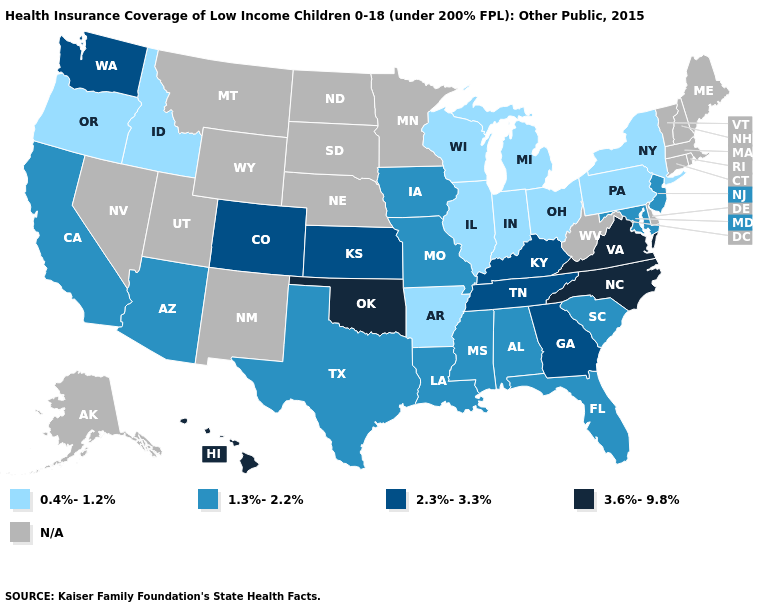Does the map have missing data?
Concise answer only. Yes. What is the value of Arkansas?
Keep it brief. 0.4%-1.2%. Which states hav the highest value in the MidWest?
Quick response, please. Kansas. Which states have the lowest value in the MidWest?
Write a very short answer. Illinois, Indiana, Michigan, Ohio, Wisconsin. Which states hav the highest value in the MidWest?
Keep it brief. Kansas. Among the states that border Oregon , which have the lowest value?
Answer briefly. Idaho. What is the value of Missouri?
Answer briefly. 1.3%-2.2%. Among the states that border New Mexico , does Texas have the highest value?
Be succinct. No. Does the first symbol in the legend represent the smallest category?
Quick response, please. Yes. Does the map have missing data?
Give a very brief answer. Yes. Which states have the lowest value in the South?
Concise answer only. Arkansas. How many symbols are there in the legend?
Short answer required. 5. What is the highest value in the South ?
Concise answer only. 3.6%-9.8%. 